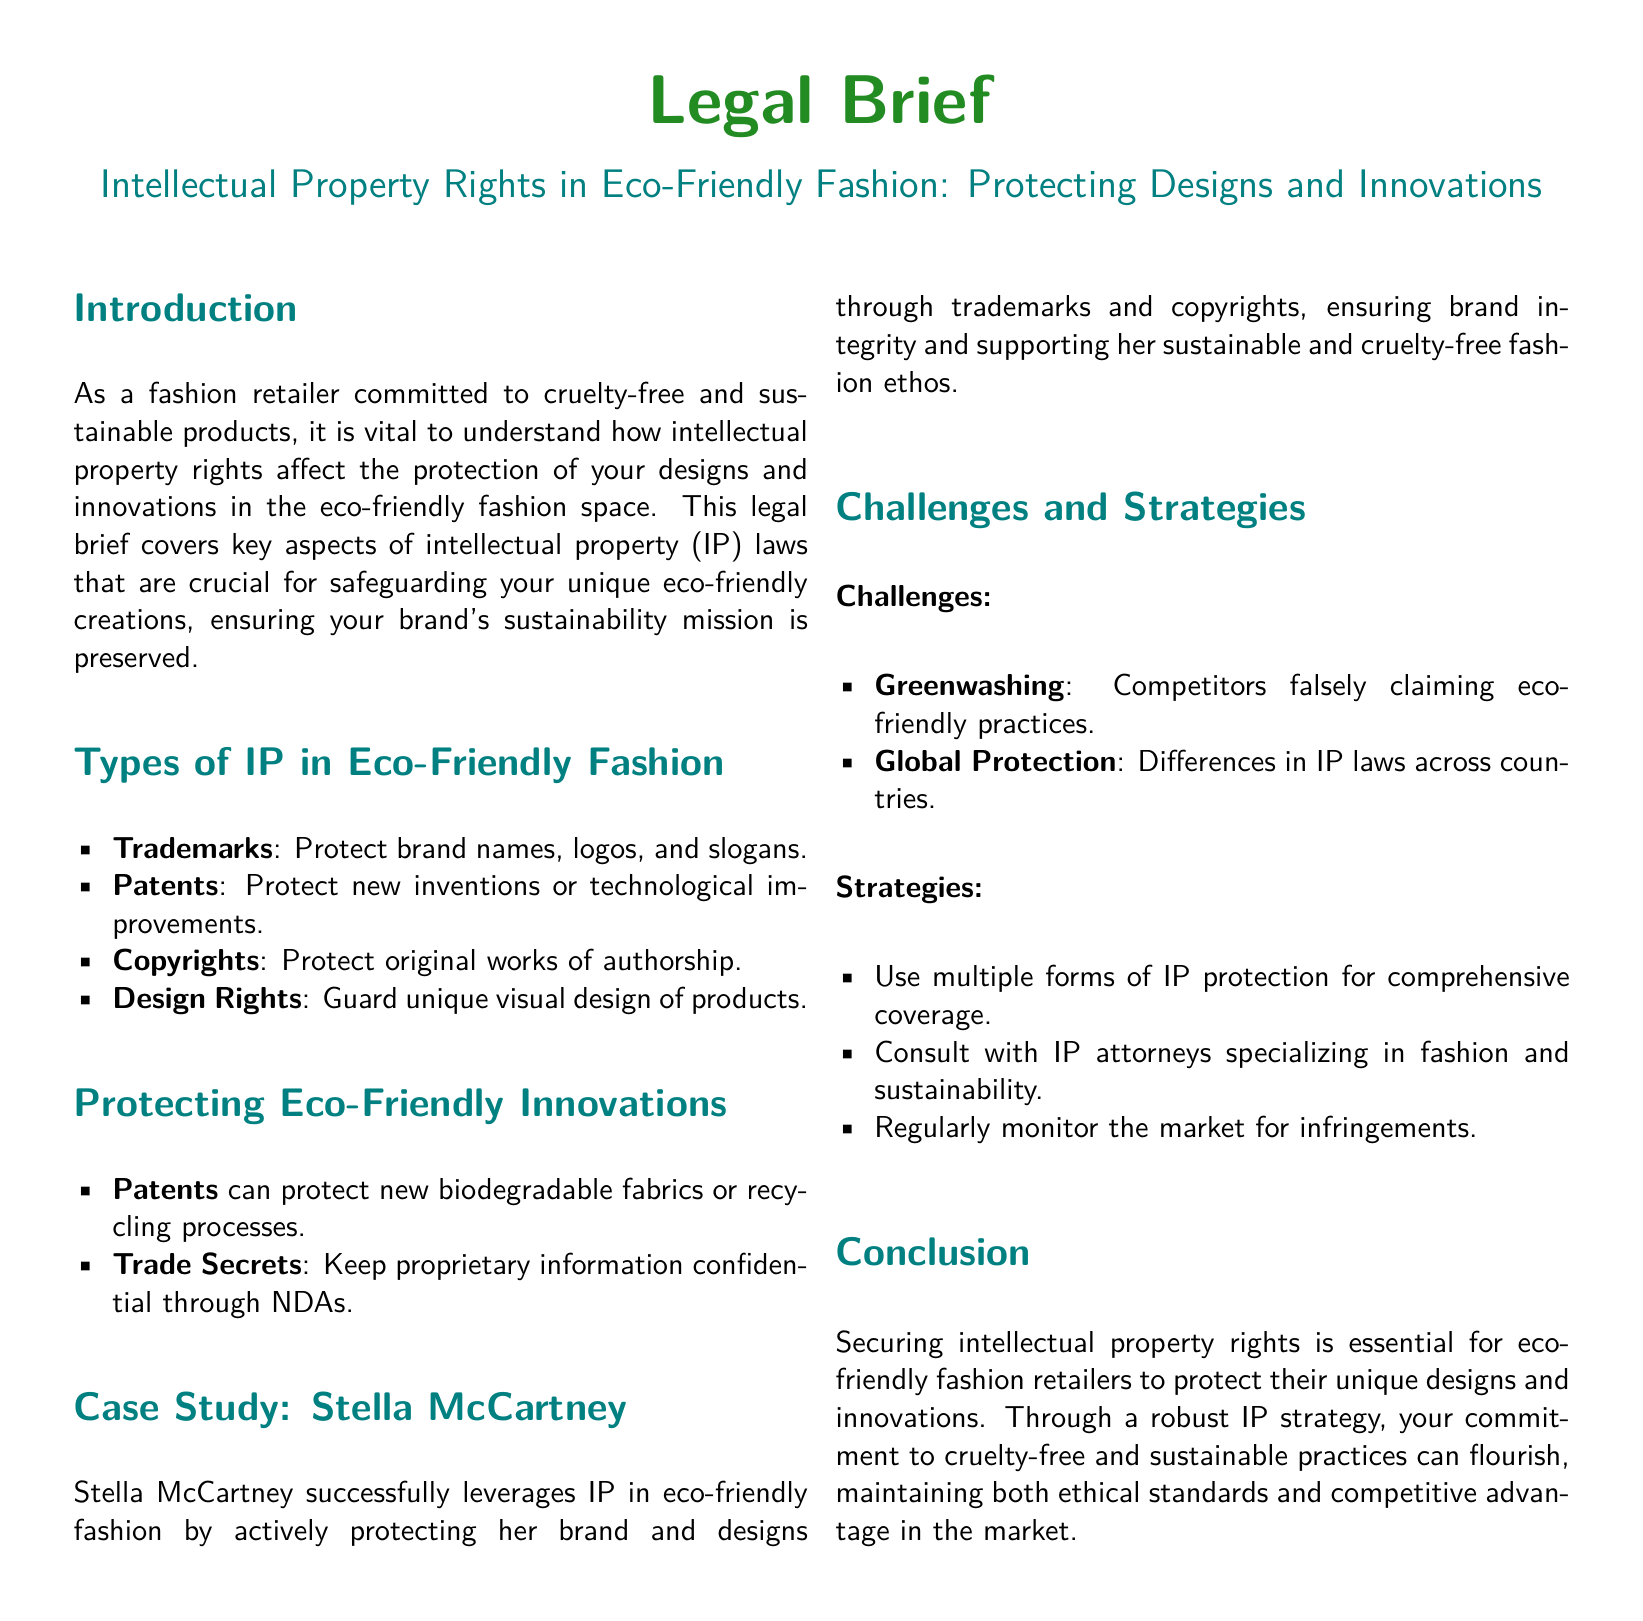What is the document title? The title of the document is located at the beginning under the main heading in a larger font, which is a common feature for legal briefs.
Answer: Intellectual Property Rights in Eco-Friendly Fashion: Protecting Designs and Innovations What type of brand does the document discuss? The document focuses on a type of brand that is dedicated to sustainability and cruelty-free practices, as described in the introduction.
Answer: Eco-friendly fashion What type of IP protects brand names and logos? The specific type of intellectual property mentioned for protecting brand names and logos is listed in the section about types of IP.
Answer: Trademarks Which case study is mentioned in the document? The case study referred to showcases a well-known eco-conscious designer, making it relevant to the discussion of IP in fashion.
Answer: Stella McCartney What is one of the challenges in eco-friendly fashion mentioned? One challenge faced by the industry and mentioned in the document involves competitors misleading the public about their practices.
Answer: Greenwashing How can new biodegradable fabrics be protected? The document suggests that this type of innovation can be safeguarded through a specific form of intellectual property mentioned in the protection section.
Answer: Patents What is advised to monitor for potential IP infringements? The document provides a strategy on how to maintain awareness and protect designs in the market, referring to a specific activity.
Answer: Monitor the market What color is used for the section titles? The color used for the section titles can be found at the beginning of the document and is important to the visual style of the brief.
Answer: Ecoblue 